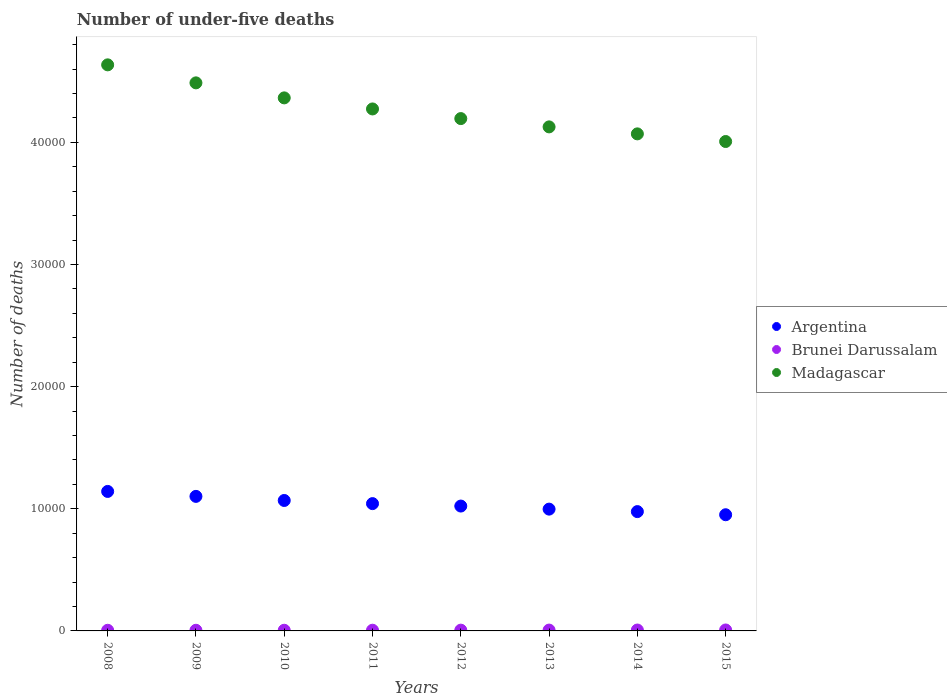Is the number of dotlines equal to the number of legend labels?
Ensure brevity in your answer.  Yes. What is the number of under-five deaths in Argentina in 2011?
Provide a succinct answer. 1.04e+04. Across all years, what is the maximum number of under-five deaths in Argentina?
Provide a short and direct response. 1.14e+04. Across all years, what is the minimum number of under-five deaths in Argentina?
Your answer should be very brief. 9513. In which year was the number of under-five deaths in Madagascar minimum?
Your answer should be very brief. 2015. What is the total number of under-five deaths in Brunei Darussalam in the graph?
Your answer should be very brief. 502. What is the difference between the number of under-five deaths in Madagascar in 2008 and that in 2009?
Your response must be concise. 1475. What is the difference between the number of under-five deaths in Madagascar in 2013 and the number of under-five deaths in Argentina in 2010?
Your answer should be compact. 3.06e+04. What is the average number of under-five deaths in Brunei Darussalam per year?
Make the answer very short. 62.75. In the year 2013, what is the difference between the number of under-five deaths in Madagascar and number of under-five deaths in Argentina?
Ensure brevity in your answer.  3.13e+04. What is the ratio of the number of under-five deaths in Madagascar in 2010 to that in 2014?
Provide a short and direct response. 1.07. What is the difference between the highest and the second highest number of under-five deaths in Argentina?
Ensure brevity in your answer.  405. What is the difference between the highest and the lowest number of under-five deaths in Argentina?
Your answer should be compact. 1909. Is the sum of the number of under-five deaths in Brunei Darussalam in 2008 and 2011 greater than the maximum number of under-five deaths in Madagascar across all years?
Ensure brevity in your answer.  No. Is the number of under-five deaths in Argentina strictly greater than the number of under-five deaths in Madagascar over the years?
Your answer should be very brief. No. Is the number of under-five deaths in Madagascar strictly less than the number of under-five deaths in Argentina over the years?
Your response must be concise. No. How many dotlines are there?
Provide a succinct answer. 3. How many years are there in the graph?
Your response must be concise. 8. What is the difference between two consecutive major ticks on the Y-axis?
Make the answer very short. 10000. Does the graph contain any zero values?
Make the answer very short. No. How many legend labels are there?
Keep it short and to the point. 3. What is the title of the graph?
Your answer should be very brief. Number of under-five deaths. Does "Peru" appear as one of the legend labels in the graph?
Your answer should be very brief. No. What is the label or title of the X-axis?
Provide a short and direct response. Years. What is the label or title of the Y-axis?
Your answer should be compact. Number of deaths. What is the Number of deaths in Argentina in 2008?
Your response must be concise. 1.14e+04. What is the Number of deaths of Madagascar in 2008?
Make the answer very short. 4.64e+04. What is the Number of deaths of Argentina in 2009?
Your answer should be very brief. 1.10e+04. What is the Number of deaths in Brunei Darussalam in 2009?
Offer a terse response. 53. What is the Number of deaths of Madagascar in 2009?
Give a very brief answer. 4.49e+04. What is the Number of deaths of Argentina in 2010?
Your answer should be very brief. 1.07e+04. What is the Number of deaths in Madagascar in 2010?
Offer a terse response. 4.36e+04. What is the Number of deaths in Argentina in 2011?
Give a very brief answer. 1.04e+04. What is the Number of deaths of Brunei Darussalam in 2011?
Make the answer very short. 58. What is the Number of deaths of Madagascar in 2011?
Give a very brief answer. 4.27e+04. What is the Number of deaths of Argentina in 2012?
Your answer should be very brief. 1.02e+04. What is the Number of deaths of Madagascar in 2012?
Provide a short and direct response. 4.20e+04. What is the Number of deaths in Argentina in 2013?
Your response must be concise. 9973. What is the Number of deaths in Madagascar in 2013?
Provide a short and direct response. 4.13e+04. What is the Number of deaths of Argentina in 2014?
Keep it short and to the point. 9770. What is the Number of deaths of Brunei Darussalam in 2014?
Offer a very short reply. 74. What is the Number of deaths in Madagascar in 2014?
Your answer should be compact. 4.07e+04. What is the Number of deaths in Argentina in 2015?
Provide a short and direct response. 9513. What is the Number of deaths of Brunei Darussalam in 2015?
Provide a short and direct response. 77. What is the Number of deaths of Madagascar in 2015?
Make the answer very short. 4.01e+04. Across all years, what is the maximum Number of deaths in Argentina?
Give a very brief answer. 1.14e+04. Across all years, what is the maximum Number of deaths in Brunei Darussalam?
Your answer should be compact. 77. Across all years, what is the maximum Number of deaths in Madagascar?
Give a very brief answer. 4.64e+04. Across all years, what is the minimum Number of deaths of Argentina?
Provide a short and direct response. 9513. Across all years, what is the minimum Number of deaths of Brunei Darussalam?
Make the answer very short. 53. Across all years, what is the minimum Number of deaths in Madagascar?
Ensure brevity in your answer.  4.01e+04. What is the total Number of deaths in Argentina in the graph?
Provide a short and direct response. 8.30e+04. What is the total Number of deaths of Brunei Darussalam in the graph?
Keep it short and to the point. 502. What is the total Number of deaths of Madagascar in the graph?
Make the answer very short. 3.42e+05. What is the difference between the Number of deaths in Argentina in 2008 and that in 2009?
Offer a very short reply. 405. What is the difference between the Number of deaths of Brunei Darussalam in 2008 and that in 2009?
Your response must be concise. 0. What is the difference between the Number of deaths in Madagascar in 2008 and that in 2009?
Keep it short and to the point. 1475. What is the difference between the Number of deaths of Argentina in 2008 and that in 2010?
Your answer should be very brief. 741. What is the difference between the Number of deaths of Brunei Darussalam in 2008 and that in 2010?
Your answer should be very brief. -2. What is the difference between the Number of deaths in Madagascar in 2008 and that in 2010?
Offer a terse response. 2705. What is the difference between the Number of deaths in Argentina in 2008 and that in 2011?
Provide a short and direct response. 998. What is the difference between the Number of deaths of Madagascar in 2008 and that in 2011?
Your answer should be very brief. 3611. What is the difference between the Number of deaths in Argentina in 2008 and that in 2012?
Provide a short and direct response. 1198. What is the difference between the Number of deaths in Brunei Darussalam in 2008 and that in 2012?
Give a very brief answer. -10. What is the difference between the Number of deaths in Madagascar in 2008 and that in 2012?
Your answer should be very brief. 4400. What is the difference between the Number of deaths of Argentina in 2008 and that in 2013?
Provide a short and direct response. 1449. What is the difference between the Number of deaths in Madagascar in 2008 and that in 2013?
Keep it short and to the point. 5080. What is the difference between the Number of deaths in Argentina in 2008 and that in 2014?
Make the answer very short. 1652. What is the difference between the Number of deaths in Madagascar in 2008 and that in 2014?
Your answer should be compact. 5652. What is the difference between the Number of deaths in Argentina in 2008 and that in 2015?
Give a very brief answer. 1909. What is the difference between the Number of deaths of Brunei Darussalam in 2008 and that in 2015?
Your answer should be very brief. -24. What is the difference between the Number of deaths of Madagascar in 2008 and that in 2015?
Offer a terse response. 6277. What is the difference between the Number of deaths in Argentina in 2009 and that in 2010?
Provide a short and direct response. 336. What is the difference between the Number of deaths in Madagascar in 2009 and that in 2010?
Make the answer very short. 1230. What is the difference between the Number of deaths in Argentina in 2009 and that in 2011?
Provide a short and direct response. 593. What is the difference between the Number of deaths in Brunei Darussalam in 2009 and that in 2011?
Provide a succinct answer. -5. What is the difference between the Number of deaths of Madagascar in 2009 and that in 2011?
Your response must be concise. 2136. What is the difference between the Number of deaths in Argentina in 2009 and that in 2012?
Give a very brief answer. 793. What is the difference between the Number of deaths in Brunei Darussalam in 2009 and that in 2012?
Offer a terse response. -10. What is the difference between the Number of deaths of Madagascar in 2009 and that in 2012?
Ensure brevity in your answer.  2925. What is the difference between the Number of deaths in Argentina in 2009 and that in 2013?
Make the answer very short. 1044. What is the difference between the Number of deaths of Madagascar in 2009 and that in 2013?
Ensure brevity in your answer.  3605. What is the difference between the Number of deaths of Argentina in 2009 and that in 2014?
Offer a very short reply. 1247. What is the difference between the Number of deaths in Brunei Darussalam in 2009 and that in 2014?
Give a very brief answer. -21. What is the difference between the Number of deaths of Madagascar in 2009 and that in 2014?
Provide a succinct answer. 4177. What is the difference between the Number of deaths of Argentina in 2009 and that in 2015?
Ensure brevity in your answer.  1504. What is the difference between the Number of deaths of Madagascar in 2009 and that in 2015?
Provide a succinct answer. 4802. What is the difference between the Number of deaths in Argentina in 2010 and that in 2011?
Your answer should be compact. 257. What is the difference between the Number of deaths of Madagascar in 2010 and that in 2011?
Ensure brevity in your answer.  906. What is the difference between the Number of deaths in Argentina in 2010 and that in 2012?
Your response must be concise. 457. What is the difference between the Number of deaths of Brunei Darussalam in 2010 and that in 2012?
Provide a short and direct response. -8. What is the difference between the Number of deaths of Madagascar in 2010 and that in 2012?
Make the answer very short. 1695. What is the difference between the Number of deaths of Argentina in 2010 and that in 2013?
Make the answer very short. 708. What is the difference between the Number of deaths of Brunei Darussalam in 2010 and that in 2013?
Your answer should be very brief. -14. What is the difference between the Number of deaths of Madagascar in 2010 and that in 2013?
Ensure brevity in your answer.  2375. What is the difference between the Number of deaths of Argentina in 2010 and that in 2014?
Your answer should be compact. 911. What is the difference between the Number of deaths of Madagascar in 2010 and that in 2014?
Provide a short and direct response. 2947. What is the difference between the Number of deaths of Argentina in 2010 and that in 2015?
Provide a succinct answer. 1168. What is the difference between the Number of deaths in Madagascar in 2010 and that in 2015?
Give a very brief answer. 3572. What is the difference between the Number of deaths of Argentina in 2011 and that in 2012?
Keep it short and to the point. 200. What is the difference between the Number of deaths in Brunei Darussalam in 2011 and that in 2012?
Provide a short and direct response. -5. What is the difference between the Number of deaths of Madagascar in 2011 and that in 2012?
Your answer should be compact. 789. What is the difference between the Number of deaths in Argentina in 2011 and that in 2013?
Provide a short and direct response. 451. What is the difference between the Number of deaths in Brunei Darussalam in 2011 and that in 2013?
Provide a succinct answer. -11. What is the difference between the Number of deaths in Madagascar in 2011 and that in 2013?
Provide a succinct answer. 1469. What is the difference between the Number of deaths of Argentina in 2011 and that in 2014?
Provide a succinct answer. 654. What is the difference between the Number of deaths of Brunei Darussalam in 2011 and that in 2014?
Ensure brevity in your answer.  -16. What is the difference between the Number of deaths of Madagascar in 2011 and that in 2014?
Give a very brief answer. 2041. What is the difference between the Number of deaths in Argentina in 2011 and that in 2015?
Your answer should be very brief. 911. What is the difference between the Number of deaths of Madagascar in 2011 and that in 2015?
Your response must be concise. 2666. What is the difference between the Number of deaths in Argentina in 2012 and that in 2013?
Keep it short and to the point. 251. What is the difference between the Number of deaths in Madagascar in 2012 and that in 2013?
Your answer should be very brief. 680. What is the difference between the Number of deaths of Argentina in 2012 and that in 2014?
Your answer should be very brief. 454. What is the difference between the Number of deaths in Madagascar in 2012 and that in 2014?
Make the answer very short. 1252. What is the difference between the Number of deaths of Argentina in 2012 and that in 2015?
Offer a terse response. 711. What is the difference between the Number of deaths in Madagascar in 2012 and that in 2015?
Provide a succinct answer. 1877. What is the difference between the Number of deaths in Argentina in 2013 and that in 2014?
Provide a succinct answer. 203. What is the difference between the Number of deaths of Madagascar in 2013 and that in 2014?
Your answer should be compact. 572. What is the difference between the Number of deaths in Argentina in 2013 and that in 2015?
Your answer should be compact. 460. What is the difference between the Number of deaths in Brunei Darussalam in 2013 and that in 2015?
Offer a very short reply. -8. What is the difference between the Number of deaths of Madagascar in 2013 and that in 2015?
Provide a succinct answer. 1197. What is the difference between the Number of deaths of Argentina in 2014 and that in 2015?
Your answer should be compact. 257. What is the difference between the Number of deaths of Madagascar in 2014 and that in 2015?
Offer a very short reply. 625. What is the difference between the Number of deaths in Argentina in 2008 and the Number of deaths in Brunei Darussalam in 2009?
Offer a terse response. 1.14e+04. What is the difference between the Number of deaths of Argentina in 2008 and the Number of deaths of Madagascar in 2009?
Ensure brevity in your answer.  -3.35e+04. What is the difference between the Number of deaths of Brunei Darussalam in 2008 and the Number of deaths of Madagascar in 2009?
Your response must be concise. -4.48e+04. What is the difference between the Number of deaths of Argentina in 2008 and the Number of deaths of Brunei Darussalam in 2010?
Make the answer very short. 1.14e+04. What is the difference between the Number of deaths in Argentina in 2008 and the Number of deaths in Madagascar in 2010?
Make the answer very short. -3.22e+04. What is the difference between the Number of deaths of Brunei Darussalam in 2008 and the Number of deaths of Madagascar in 2010?
Offer a terse response. -4.36e+04. What is the difference between the Number of deaths in Argentina in 2008 and the Number of deaths in Brunei Darussalam in 2011?
Your answer should be very brief. 1.14e+04. What is the difference between the Number of deaths of Argentina in 2008 and the Number of deaths of Madagascar in 2011?
Ensure brevity in your answer.  -3.13e+04. What is the difference between the Number of deaths of Brunei Darussalam in 2008 and the Number of deaths of Madagascar in 2011?
Ensure brevity in your answer.  -4.27e+04. What is the difference between the Number of deaths in Argentina in 2008 and the Number of deaths in Brunei Darussalam in 2012?
Make the answer very short. 1.14e+04. What is the difference between the Number of deaths in Argentina in 2008 and the Number of deaths in Madagascar in 2012?
Your answer should be compact. -3.05e+04. What is the difference between the Number of deaths of Brunei Darussalam in 2008 and the Number of deaths of Madagascar in 2012?
Give a very brief answer. -4.19e+04. What is the difference between the Number of deaths of Argentina in 2008 and the Number of deaths of Brunei Darussalam in 2013?
Offer a very short reply. 1.14e+04. What is the difference between the Number of deaths of Argentina in 2008 and the Number of deaths of Madagascar in 2013?
Your answer should be very brief. -2.98e+04. What is the difference between the Number of deaths in Brunei Darussalam in 2008 and the Number of deaths in Madagascar in 2013?
Make the answer very short. -4.12e+04. What is the difference between the Number of deaths of Argentina in 2008 and the Number of deaths of Brunei Darussalam in 2014?
Offer a very short reply. 1.13e+04. What is the difference between the Number of deaths in Argentina in 2008 and the Number of deaths in Madagascar in 2014?
Your answer should be very brief. -2.93e+04. What is the difference between the Number of deaths in Brunei Darussalam in 2008 and the Number of deaths in Madagascar in 2014?
Provide a short and direct response. -4.06e+04. What is the difference between the Number of deaths in Argentina in 2008 and the Number of deaths in Brunei Darussalam in 2015?
Offer a very short reply. 1.13e+04. What is the difference between the Number of deaths in Argentina in 2008 and the Number of deaths in Madagascar in 2015?
Your answer should be very brief. -2.87e+04. What is the difference between the Number of deaths of Brunei Darussalam in 2008 and the Number of deaths of Madagascar in 2015?
Your response must be concise. -4.00e+04. What is the difference between the Number of deaths of Argentina in 2009 and the Number of deaths of Brunei Darussalam in 2010?
Keep it short and to the point. 1.10e+04. What is the difference between the Number of deaths of Argentina in 2009 and the Number of deaths of Madagascar in 2010?
Provide a short and direct response. -3.26e+04. What is the difference between the Number of deaths of Brunei Darussalam in 2009 and the Number of deaths of Madagascar in 2010?
Ensure brevity in your answer.  -4.36e+04. What is the difference between the Number of deaths in Argentina in 2009 and the Number of deaths in Brunei Darussalam in 2011?
Your answer should be very brief. 1.10e+04. What is the difference between the Number of deaths in Argentina in 2009 and the Number of deaths in Madagascar in 2011?
Give a very brief answer. -3.17e+04. What is the difference between the Number of deaths of Brunei Darussalam in 2009 and the Number of deaths of Madagascar in 2011?
Ensure brevity in your answer.  -4.27e+04. What is the difference between the Number of deaths of Argentina in 2009 and the Number of deaths of Brunei Darussalam in 2012?
Give a very brief answer. 1.10e+04. What is the difference between the Number of deaths of Argentina in 2009 and the Number of deaths of Madagascar in 2012?
Make the answer very short. -3.09e+04. What is the difference between the Number of deaths of Brunei Darussalam in 2009 and the Number of deaths of Madagascar in 2012?
Your answer should be very brief. -4.19e+04. What is the difference between the Number of deaths of Argentina in 2009 and the Number of deaths of Brunei Darussalam in 2013?
Make the answer very short. 1.09e+04. What is the difference between the Number of deaths in Argentina in 2009 and the Number of deaths in Madagascar in 2013?
Your answer should be compact. -3.03e+04. What is the difference between the Number of deaths in Brunei Darussalam in 2009 and the Number of deaths in Madagascar in 2013?
Make the answer very short. -4.12e+04. What is the difference between the Number of deaths in Argentina in 2009 and the Number of deaths in Brunei Darussalam in 2014?
Your answer should be very brief. 1.09e+04. What is the difference between the Number of deaths of Argentina in 2009 and the Number of deaths of Madagascar in 2014?
Your answer should be compact. -2.97e+04. What is the difference between the Number of deaths in Brunei Darussalam in 2009 and the Number of deaths in Madagascar in 2014?
Your answer should be compact. -4.06e+04. What is the difference between the Number of deaths of Argentina in 2009 and the Number of deaths of Brunei Darussalam in 2015?
Ensure brevity in your answer.  1.09e+04. What is the difference between the Number of deaths of Argentina in 2009 and the Number of deaths of Madagascar in 2015?
Provide a succinct answer. -2.91e+04. What is the difference between the Number of deaths in Brunei Darussalam in 2009 and the Number of deaths in Madagascar in 2015?
Your response must be concise. -4.00e+04. What is the difference between the Number of deaths in Argentina in 2010 and the Number of deaths in Brunei Darussalam in 2011?
Provide a short and direct response. 1.06e+04. What is the difference between the Number of deaths in Argentina in 2010 and the Number of deaths in Madagascar in 2011?
Your answer should be very brief. -3.21e+04. What is the difference between the Number of deaths of Brunei Darussalam in 2010 and the Number of deaths of Madagascar in 2011?
Offer a very short reply. -4.27e+04. What is the difference between the Number of deaths in Argentina in 2010 and the Number of deaths in Brunei Darussalam in 2012?
Provide a succinct answer. 1.06e+04. What is the difference between the Number of deaths in Argentina in 2010 and the Number of deaths in Madagascar in 2012?
Make the answer very short. -3.13e+04. What is the difference between the Number of deaths of Brunei Darussalam in 2010 and the Number of deaths of Madagascar in 2012?
Offer a very short reply. -4.19e+04. What is the difference between the Number of deaths in Argentina in 2010 and the Number of deaths in Brunei Darussalam in 2013?
Provide a succinct answer. 1.06e+04. What is the difference between the Number of deaths of Argentina in 2010 and the Number of deaths of Madagascar in 2013?
Keep it short and to the point. -3.06e+04. What is the difference between the Number of deaths of Brunei Darussalam in 2010 and the Number of deaths of Madagascar in 2013?
Keep it short and to the point. -4.12e+04. What is the difference between the Number of deaths in Argentina in 2010 and the Number of deaths in Brunei Darussalam in 2014?
Give a very brief answer. 1.06e+04. What is the difference between the Number of deaths of Argentina in 2010 and the Number of deaths of Madagascar in 2014?
Your response must be concise. -3.00e+04. What is the difference between the Number of deaths in Brunei Darussalam in 2010 and the Number of deaths in Madagascar in 2014?
Keep it short and to the point. -4.06e+04. What is the difference between the Number of deaths in Argentina in 2010 and the Number of deaths in Brunei Darussalam in 2015?
Your answer should be compact. 1.06e+04. What is the difference between the Number of deaths in Argentina in 2010 and the Number of deaths in Madagascar in 2015?
Offer a terse response. -2.94e+04. What is the difference between the Number of deaths of Brunei Darussalam in 2010 and the Number of deaths of Madagascar in 2015?
Give a very brief answer. -4.00e+04. What is the difference between the Number of deaths in Argentina in 2011 and the Number of deaths in Brunei Darussalam in 2012?
Offer a terse response. 1.04e+04. What is the difference between the Number of deaths in Argentina in 2011 and the Number of deaths in Madagascar in 2012?
Offer a very short reply. -3.15e+04. What is the difference between the Number of deaths of Brunei Darussalam in 2011 and the Number of deaths of Madagascar in 2012?
Offer a terse response. -4.19e+04. What is the difference between the Number of deaths in Argentina in 2011 and the Number of deaths in Brunei Darussalam in 2013?
Your answer should be compact. 1.04e+04. What is the difference between the Number of deaths of Argentina in 2011 and the Number of deaths of Madagascar in 2013?
Make the answer very short. -3.08e+04. What is the difference between the Number of deaths in Brunei Darussalam in 2011 and the Number of deaths in Madagascar in 2013?
Provide a succinct answer. -4.12e+04. What is the difference between the Number of deaths in Argentina in 2011 and the Number of deaths in Brunei Darussalam in 2014?
Offer a very short reply. 1.04e+04. What is the difference between the Number of deaths of Argentina in 2011 and the Number of deaths of Madagascar in 2014?
Provide a short and direct response. -3.03e+04. What is the difference between the Number of deaths in Brunei Darussalam in 2011 and the Number of deaths in Madagascar in 2014?
Your response must be concise. -4.06e+04. What is the difference between the Number of deaths of Argentina in 2011 and the Number of deaths of Brunei Darussalam in 2015?
Keep it short and to the point. 1.03e+04. What is the difference between the Number of deaths of Argentina in 2011 and the Number of deaths of Madagascar in 2015?
Keep it short and to the point. -2.97e+04. What is the difference between the Number of deaths of Brunei Darussalam in 2011 and the Number of deaths of Madagascar in 2015?
Give a very brief answer. -4.00e+04. What is the difference between the Number of deaths of Argentina in 2012 and the Number of deaths of Brunei Darussalam in 2013?
Offer a terse response. 1.02e+04. What is the difference between the Number of deaths of Argentina in 2012 and the Number of deaths of Madagascar in 2013?
Provide a succinct answer. -3.10e+04. What is the difference between the Number of deaths in Brunei Darussalam in 2012 and the Number of deaths in Madagascar in 2013?
Keep it short and to the point. -4.12e+04. What is the difference between the Number of deaths of Argentina in 2012 and the Number of deaths of Brunei Darussalam in 2014?
Give a very brief answer. 1.02e+04. What is the difference between the Number of deaths in Argentina in 2012 and the Number of deaths in Madagascar in 2014?
Make the answer very short. -3.05e+04. What is the difference between the Number of deaths in Brunei Darussalam in 2012 and the Number of deaths in Madagascar in 2014?
Keep it short and to the point. -4.06e+04. What is the difference between the Number of deaths in Argentina in 2012 and the Number of deaths in Brunei Darussalam in 2015?
Provide a succinct answer. 1.01e+04. What is the difference between the Number of deaths in Argentina in 2012 and the Number of deaths in Madagascar in 2015?
Your response must be concise. -2.99e+04. What is the difference between the Number of deaths in Brunei Darussalam in 2012 and the Number of deaths in Madagascar in 2015?
Provide a succinct answer. -4.00e+04. What is the difference between the Number of deaths of Argentina in 2013 and the Number of deaths of Brunei Darussalam in 2014?
Offer a very short reply. 9899. What is the difference between the Number of deaths of Argentina in 2013 and the Number of deaths of Madagascar in 2014?
Provide a short and direct response. -3.07e+04. What is the difference between the Number of deaths in Brunei Darussalam in 2013 and the Number of deaths in Madagascar in 2014?
Ensure brevity in your answer.  -4.06e+04. What is the difference between the Number of deaths in Argentina in 2013 and the Number of deaths in Brunei Darussalam in 2015?
Your response must be concise. 9896. What is the difference between the Number of deaths in Argentina in 2013 and the Number of deaths in Madagascar in 2015?
Offer a terse response. -3.01e+04. What is the difference between the Number of deaths of Brunei Darussalam in 2013 and the Number of deaths of Madagascar in 2015?
Your response must be concise. -4.00e+04. What is the difference between the Number of deaths of Argentina in 2014 and the Number of deaths of Brunei Darussalam in 2015?
Provide a short and direct response. 9693. What is the difference between the Number of deaths in Argentina in 2014 and the Number of deaths in Madagascar in 2015?
Offer a terse response. -3.03e+04. What is the difference between the Number of deaths of Brunei Darussalam in 2014 and the Number of deaths of Madagascar in 2015?
Ensure brevity in your answer.  -4.00e+04. What is the average Number of deaths of Argentina per year?
Provide a succinct answer. 1.04e+04. What is the average Number of deaths of Brunei Darussalam per year?
Provide a succinct answer. 62.75. What is the average Number of deaths in Madagascar per year?
Offer a terse response. 4.27e+04. In the year 2008, what is the difference between the Number of deaths in Argentina and Number of deaths in Brunei Darussalam?
Keep it short and to the point. 1.14e+04. In the year 2008, what is the difference between the Number of deaths in Argentina and Number of deaths in Madagascar?
Ensure brevity in your answer.  -3.49e+04. In the year 2008, what is the difference between the Number of deaths in Brunei Darussalam and Number of deaths in Madagascar?
Ensure brevity in your answer.  -4.63e+04. In the year 2009, what is the difference between the Number of deaths in Argentina and Number of deaths in Brunei Darussalam?
Your response must be concise. 1.10e+04. In the year 2009, what is the difference between the Number of deaths of Argentina and Number of deaths of Madagascar?
Make the answer very short. -3.39e+04. In the year 2009, what is the difference between the Number of deaths of Brunei Darussalam and Number of deaths of Madagascar?
Your answer should be very brief. -4.48e+04. In the year 2010, what is the difference between the Number of deaths of Argentina and Number of deaths of Brunei Darussalam?
Give a very brief answer. 1.06e+04. In the year 2010, what is the difference between the Number of deaths in Argentina and Number of deaths in Madagascar?
Your answer should be very brief. -3.30e+04. In the year 2010, what is the difference between the Number of deaths in Brunei Darussalam and Number of deaths in Madagascar?
Offer a terse response. -4.36e+04. In the year 2011, what is the difference between the Number of deaths of Argentina and Number of deaths of Brunei Darussalam?
Offer a very short reply. 1.04e+04. In the year 2011, what is the difference between the Number of deaths in Argentina and Number of deaths in Madagascar?
Give a very brief answer. -3.23e+04. In the year 2011, what is the difference between the Number of deaths in Brunei Darussalam and Number of deaths in Madagascar?
Make the answer very short. -4.27e+04. In the year 2012, what is the difference between the Number of deaths in Argentina and Number of deaths in Brunei Darussalam?
Offer a terse response. 1.02e+04. In the year 2012, what is the difference between the Number of deaths of Argentina and Number of deaths of Madagascar?
Provide a succinct answer. -3.17e+04. In the year 2012, what is the difference between the Number of deaths in Brunei Darussalam and Number of deaths in Madagascar?
Ensure brevity in your answer.  -4.19e+04. In the year 2013, what is the difference between the Number of deaths of Argentina and Number of deaths of Brunei Darussalam?
Provide a short and direct response. 9904. In the year 2013, what is the difference between the Number of deaths in Argentina and Number of deaths in Madagascar?
Make the answer very short. -3.13e+04. In the year 2013, what is the difference between the Number of deaths in Brunei Darussalam and Number of deaths in Madagascar?
Ensure brevity in your answer.  -4.12e+04. In the year 2014, what is the difference between the Number of deaths of Argentina and Number of deaths of Brunei Darussalam?
Your answer should be compact. 9696. In the year 2014, what is the difference between the Number of deaths of Argentina and Number of deaths of Madagascar?
Provide a short and direct response. -3.09e+04. In the year 2014, what is the difference between the Number of deaths in Brunei Darussalam and Number of deaths in Madagascar?
Your response must be concise. -4.06e+04. In the year 2015, what is the difference between the Number of deaths in Argentina and Number of deaths in Brunei Darussalam?
Provide a short and direct response. 9436. In the year 2015, what is the difference between the Number of deaths in Argentina and Number of deaths in Madagascar?
Offer a very short reply. -3.06e+04. In the year 2015, what is the difference between the Number of deaths in Brunei Darussalam and Number of deaths in Madagascar?
Offer a terse response. -4.00e+04. What is the ratio of the Number of deaths in Argentina in 2008 to that in 2009?
Ensure brevity in your answer.  1.04. What is the ratio of the Number of deaths of Madagascar in 2008 to that in 2009?
Ensure brevity in your answer.  1.03. What is the ratio of the Number of deaths in Argentina in 2008 to that in 2010?
Provide a short and direct response. 1.07. What is the ratio of the Number of deaths in Brunei Darussalam in 2008 to that in 2010?
Your response must be concise. 0.96. What is the ratio of the Number of deaths of Madagascar in 2008 to that in 2010?
Keep it short and to the point. 1.06. What is the ratio of the Number of deaths of Argentina in 2008 to that in 2011?
Keep it short and to the point. 1.1. What is the ratio of the Number of deaths of Brunei Darussalam in 2008 to that in 2011?
Provide a succinct answer. 0.91. What is the ratio of the Number of deaths in Madagascar in 2008 to that in 2011?
Your answer should be very brief. 1.08. What is the ratio of the Number of deaths of Argentina in 2008 to that in 2012?
Ensure brevity in your answer.  1.12. What is the ratio of the Number of deaths of Brunei Darussalam in 2008 to that in 2012?
Make the answer very short. 0.84. What is the ratio of the Number of deaths of Madagascar in 2008 to that in 2012?
Provide a short and direct response. 1.1. What is the ratio of the Number of deaths in Argentina in 2008 to that in 2013?
Offer a terse response. 1.15. What is the ratio of the Number of deaths in Brunei Darussalam in 2008 to that in 2013?
Your response must be concise. 0.77. What is the ratio of the Number of deaths in Madagascar in 2008 to that in 2013?
Offer a very short reply. 1.12. What is the ratio of the Number of deaths of Argentina in 2008 to that in 2014?
Provide a succinct answer. 1.17. What is the ratio of the Number of deaths of Brunei Darussalam in 2008 to that in 2014?
Your response must be concise. 0.72. What is the ratio of the Number of deaths of Madagascar in 2008 to that in 2014?
Ensure brevity in your answer.  1.14. What is the ratio of the Number of deaths in Argentina in 2008 to that in 2015?
Keep it short and to the point. 1.2. What is the ratio of the Number of deaths in Brunei Darussalam in 2008 to that in 2015?
Offer a very short reply. 0.69. What is the ratio of the Number of deaths in Madagascar in 2008 to that in 2015?
Keep it short and to the point. 1.16. What is the ratio of the Number of deaths in Argentina in 2009 to that in 2010?
Your answer should be very brief. 1.03. What is the ratio of the Number of deaths of Brunei Darussalam in 2009 to that in 2010?
Provide a short and direct response. 0.96. What is the ratio of the Number of deaths in Madagascar in 2009 to that in 2010?
Your answer should be compact. 1.03. What is the ratio of the Number of deaths in Argentina in 2009 to that in 2011?
Keep it short and to the point. 1.06. What is the ratio of the Number of deaths in Brunei Darussalam in 2009 to that in 2011?
Keep it short and to the point. 0.91. What is the ratio of the Number of deaths in Madagascar in 2009 to that in 2011?
Your answer should be very brief. 1.05. What is the ratio of the Number of deaths of Argentina in 2009 to that in 2012?
Your answer should be very brief. 1.08. What is the ratio of the Number of deaths of Brunei Darussalam in 2009 to that in 2012?
Your answer should be very brief. 0.84. What is the ratio of the Number of deaths in Madagascar in 2009 to that in 2012?
Ensure brevity in your answer.  1.07. What is the ratio of the Number of deaths of Argentina in 2009 to that in 2013?
Make the answer very short. 1.1. What is the ratio of the Number of deaths in Brunei Darussalam in 2009 to that in 2013?
Your answer should be compact. 0.77. What is the ratio of the Number of deaths of Madagascar in 2009 to that in 2013?
Offer a terse response. 1.09. What is the ratio of the Number of deaths in Argentina in 2009 to that in 2014?
Your answer should be very brief. 1.13. What is the ratio of the Number of deaths of Brunei Darussalam in 2009 to that in 2014?
Your response must be concise. 0.72. What is the ratio of the Number of deaths in Madagascar in 2009 to that in 2014?
Ensure brevity in your answer.  1.1. What is the ratio of the Number of deaths of Argentina in 2009 to that in 2015?
Offer a terse response. 1.16. What is the ratio of the Number of deaths in Brunei Darussalam in 2009 to that in 2015?
Keep it short and to the point. 0.69. What is the ratio of the Number of deaths of Madagascar in 2009 to that in 2015?
Ensure brevity in your answer.  1.12. What is the ratio of the Number of deaths in Argentina in 2010 to that in 2011?
Give a very brief answer. 1.02. What is the ratio of the Number of deaths of Brunei Darussalam in 2010 to that in 2011?
Provide a succinct answer. 0.95. What is the ratio of the Number of deaths of Madagascar in 2010 to that in 2011?
Offer a very short reply. 1.02. What is the ratio of the Number of deaths in Argentina in 2010 to that in 2012?
Provide a short and direct response. 1.04. What is the ratio of the Number of deaths in Brunei Darussalam in 2010 to that in 2012?
Your answer should be compact. 0.87. What is the ratio of the Number of deaths in Madagascar in 2010 to that in 2012?
Your response must be concise. 1.04. What is the ratio of the Number of deaths in Argentina in 2010 to that in 2013?
Your response must be concise. 1.07. What is the ratio of the Number of deaths in Brunei Darussalam in 2010 to that in 2013?
Provide a succinct answer. 0.8. What is the ratio of the Number of deaths of Madagascar in 2010 to that in 2013?
Give a very brief answer. 1.06. What is the ratio of the Number of deaths in Argentina in 2010 to that in 2014?
Your answer should be very brief. 1.09. What is the ratio of the Number of deaths of Brunei Darussalam in 2010 to that in 2014?
Your response must be concise. 0.74. What is the ratio of the Number of deaths in Madagascar in 2010 to that in 2014?
Make the answer very short. 1.07. What is the ratio of the Number of deaths in Argentina in 2010 to that in 2015?
Keep it short and to the point. 1.12. What is the ratio of the Number of deaths in Madagascar in 2010 to that in 2015?
Make the answer very short. 1.09. What is the ratio of the Number of deaths in Argentina in 2011 to that in 2012?
Provide a succinct answer. 1.02. What is the ratio of the Number of deaths of Brunei Darussalam in 2011 to that in 2012?
Give a very brief answer. 0.92. What is the ratio of the Number of deaths in Madagascar in 2011 to that in 2012?
Offer a terse response. 1.02. What is the ratio of the Number of deaths of Argentina in 2011 to that in 2013?
Your answer should be very brief. 1.05. What is the ratio of the Number of deaths in Brunei Darussalam in 2011 to that in 2013?
Keep it short and to the point. 0.84. What is the ratio of the Number of deaths in Madagascar in 2011 to that in 2013?
Your response must be concise. 1.04. What is the ratio of the Number of deaths in Argentina in 2011 to that in 2014?
Offer a very short reply. 1.07. What is the ratio of the Number of deaths in Brunei Darussalam in 2011 to that in 2014?
Offer a very short reply. 0.78. What is the ratio of the Number of deaths of Madagascar in 2011 to that in 2014?
Provide a succinct answer. 1.05. What is the ratio of the Number of deaths of Argentina in 2011 to that in 2015?
Provide a short and direct response. 1.1. What is the ratio of the Number of deaths of Brunei Darussalam in 2011 to that in 2015?
Offer a terse response. 0.75. What is the ratio of the Number of deaths in Madagascar in 2011 to that in 2015?
Provide a short and direct response. 1.07. What is the ratio of the Number of deaths in Argentina in 2012 to that in 2013?
Your answer should be compact. 1.03. What is the ratio of the Number of deaths of Madagascar in 2012 to that in 2013?
Provide a short and direct response. 1.02. What is the ratio of the Number of deaths of Argentina in 2012 to that in 2014?
Your response must be concise. 1.05. What is the ratio of the Number of deaths in Brunei Darussalam in 2012 to that in 2014?
Make the answer very short. 0.85. What is the ratio of the Number of deaths in Madagascar in 2012 to that in 2014?
Your answer should be very brief. 1.03. What is the ratio of the Number of deaths of Argentina in 2012 to that in 2015?
Offer a terse response. 1.07. What is the ratio of the Number of deaths of Brunei Darussalam in 2012 to that in 2015?
Offer a terse response. 0.82. What is the ratio of the Number of deaths of Madagascar in 2012 to that in 2015?
Your answer should be compact. 1.05. What is the ratio of the Number of deaths in Argentina in 2013 to that in 2014?
Your response must be concise. 1.02. What is the ratio of the Number of deaths in Brunei Darussalam in 2013 to that in 2014?
Provide a succinct answer. 0.93. What is the ratio of the Number of deaths of Madagascar in 2013 to that in 2014?
Your answer should be very brief. 1.01. What is the ratio of the Number of deaths of Argentina in 2013 to that in 2015?
Offer a very short reply. 1.05. What is the ratio of the Number of deaths of Brunei Darussalam in 2013 to that in 2015?
Offer a terse response. 0.9. What is the ratio of the Number of deaths in Madagascar in 2013 to that in 2015?
Keep it short and to the point. 1.03. What is the ratio of the Number of deaths of Argentina in 2014 to that in 2015?
Your answer should be very brief. 1.03. What is the ratio of the Number of deaths of Madagascar in 2014 to that in 2015?
Give a very brief answer. 1.02. What is the difference between the highest and the second highest Number of deaths in Argentina?
Give a very brief answer. 405. What is the difference between the highest and the second highest Number of deaths in Madagascar?
Offer a terse response. 1475. What is the difference between the highest and the lowest Number of deaths of Argentina?
Provide a succinct answer. 1909. What is the difference between the highest and the lowest Number of deaths in Madagascar?
Your answer should be compact. 6277. 